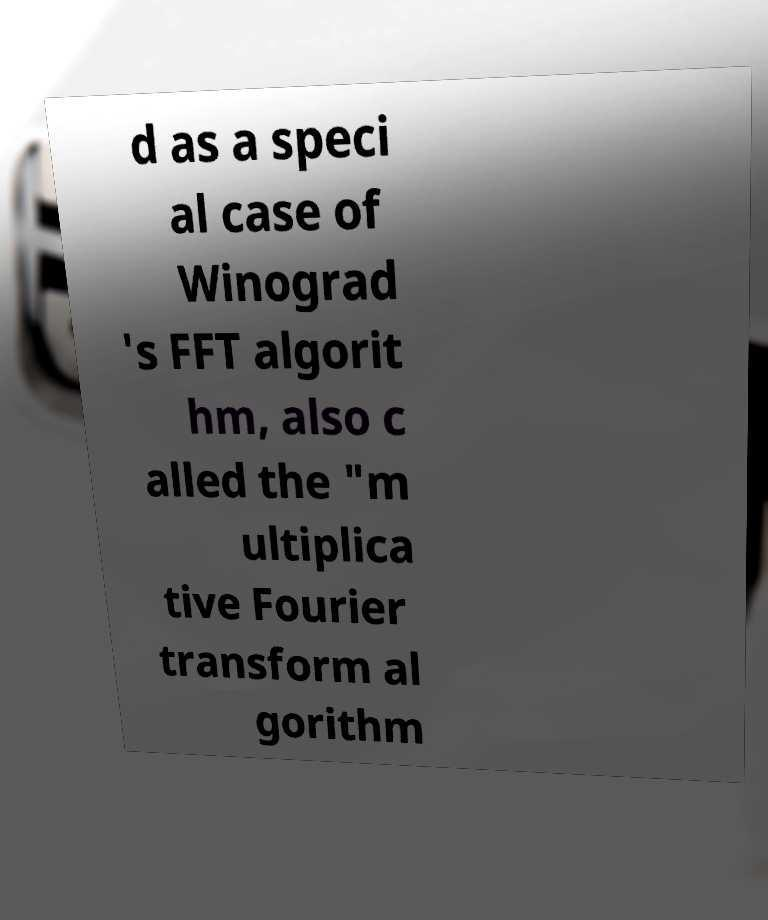For documentation purposes, I need the text within this image transcribed. Could you provide that? d as a speci al case of Winograd 's FFT algorit hm, also c alled the "m ultiplica tive Fourier transform al gorithm 